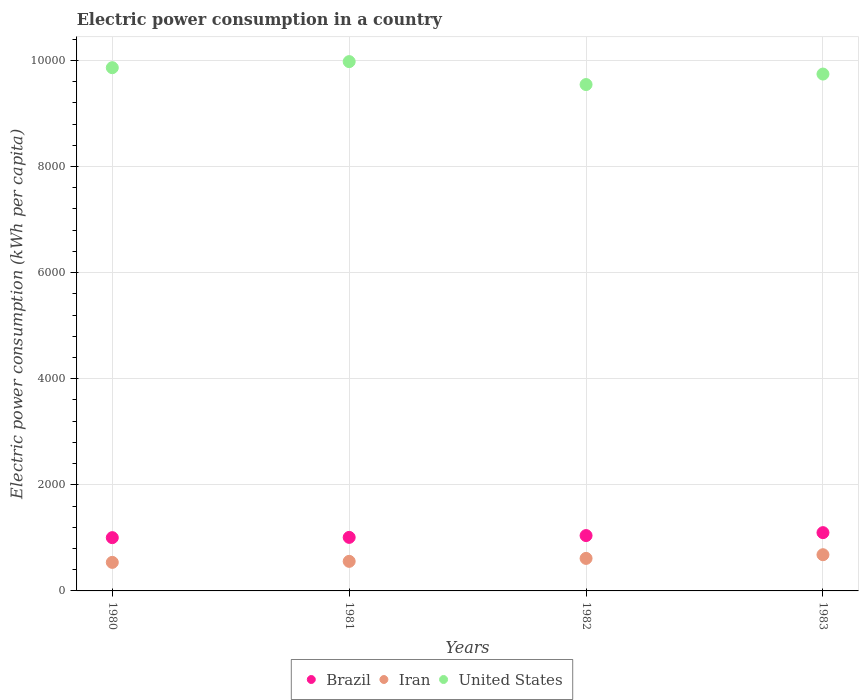How many different coloured dotlines are there?
Offer a very short reply. 3. What is the electric power consumption in in Brazil in 1980?
Provide a short and direct response. 1004.13. Across all years, what is the maximum electric power consumption in in United States?
Keep it short and to the point. 9976.69. Across all years, what is the minimum electric power consumption in in Iran?
Keep it short and to the point. 537.91. In which year was the electric power consumption in in Iran maximum?
Keep it short and to the point. 1983. What is the total electric power consumption in in Iran in the graph?
Offer a terse response. 2390.61. What is the difference between the electric power consumption in in Iran in 1982 and that in 1983?
Your answer should be compact. -69.37. What is the difference between the electric power consumption in in United States in 1983 and the electric power consumption in in Brazil in 1982?
Provide a short and direct response. 8698.89. What is the average electric power consumption in in Iran per year?
Give a very brief answer. 597.65. In the year 1983, what is the difference between the electric power consumption in in United States and electric power consumption in in Brazil?
Make the answer very short. 8643.54. In how many years, is the electric power consumption in in Brazil greater than 1200 kWh per capita?
Offer a very short reply. 0. What is the ratio of the electric power consumption in in United States in 1980 to that in 1982?
Keep it short and to the point. 1.03. Is the electric power consumption in in United States in 1980 less than that in 1983?
Offer a terse response. No. What is the difference between the highest and the second highest electric power consumption in in United States?
Provide a short and direct response. 114.33. What is the difference between the highest and the lowest electric power consumption in in Brazil?
Offer a terse response. 94.34. In how many years, is the electric power consumption in in Brazil greater than the average electric power consumption in in Brazil taken over all years?
Your response must be concise. 2. Is the sum of the electric power consumption in in United States in 1981 and 1983 greater than the maximum electric power consumption in in Iran across all years?
Provide a short and direct response. Yes. Is it the case that in every year, the sum of the electric power consumption in in Iran and electric power consumption in in United States  is greater than the electric power consumption in in Brazil?
Provide a short and direct response. Yes. Is the electric power consumption in in United States strictly less than the electric power consumption in in Iran over the years?
Make the answer very short. No. How many dotlines are there?
Offer a very short reply. 3. What is the difference between two consecutive major ticks on the Y-axis?
Offer a very short reply. 2000. Are the values on the major ticks of Y-axis written in scientific E-notation?
Make the answer very short. No. What is the title of the graph?
Offer a very short reply. Electric power consumption in a country. What is the label or title of the X-axis?
Offer a terse response. Years. What is the label or title of the Y-axis?
Your answer should be very brief. Electric power consumption (kWh per capita). What is the Electric power consumption (kWh per capita) of Brazil in 1980?
Make the answer very short. 1004.13. What is the Electric power consumption (kWh per capita) of Iran in 1980?
Your answer should be compact. 537.91. What is the Electric power consumption (kWh per capita) in United States in 1980?
Your response must be concise. 9862.37. What is the Electric power consumption (kWh per capita) of Brazil in 1981?
Your answer should be compact. 1009. What is the Electric power consumption (kWh per capita) in Iran in 1981?
Keep it short and to the point. 557.31. What is the Electric power consumption (kWh per capita) of United States in 1981?
Offer a terse response. 9976.69. What is the Electric power consumption (kWh per capita) of Brazil in 1982?
Ensure brevity in your answer.  1043.12. What is the Electric power consumption (kWh per capita) of Iran in 1982?
Make the answer very short. 613.01. What is the Electric power consumption (kWh per capita) in United States in 1982?
Ensure brevity in your answer.  9544.46. What is the Electric power consumption (kWh per capita) in Brazil in 1983?
Provide a succinct answer. 1098.47. What is the Electric power consumption (kWh per capita) of Iran in 1983?
Provide a succinct answer. 682.38. What is the Electric power consumption (kWh per capita) in United States in 1983?
Your answer should be very brief. 9742.01. Across all years, what is the maximum Electric power consumption (kWh per capita) in Brazil?
Your answer should be very brief. 1098.47. Across all years, what is the maximum Electric power consumption (kWh per capita) of Iran?
Make the answer very short. 682.38. Across all years, what is the maximum Electric power consumption (kWh per capita) of United States?
Offer a very short reply. 9976.69. Across all years, what is the minimum Electric power consumption (kWh per capita) in Brazil?
Give a very brief answer. 1004.13. Across all years, what is the minimum Electric power consumption (kWh per capita) of Iran?
Your answer should be compact. 537.91. Across all years, what is the minimum Electric power consumption (kWh per capita) in United States?
Your answer should be very brief. 9544.46. What is the total Electric power consumption (kWh per capita) of Brazil in the graph?
Offer a very short reply. 4154.71. What is the total Electric power consumption (kWh per capita) in Iran in the graph?
Ensure brevity in your answer.  2390.61. What is the total Electric power consumption (kWh per capita) in United States in the graph?
Offer a very short reply. 3.91e+04. What is the difference between the Electric power consumption (kWh per capita) in Brazil in 1980 and that in 1981?
Your answer should be compact. -4.87. What is the difference between the Electric power consumption (kWh per capita) of Iran in 1980 and that in 1981?
Give a very brief answer. -19.4. What is the difference between the Electric power consumption (kWh per capita) of United States in 1980 and that in 1981?
Ensure brevity in your answer.  -114.33. What is the difference between the Electric power consumption (kWh per capita) in Brazil in 1980 and that in 1982?
Your answer should be very brief. -38.99. What is the difference between the Electric power consumption (kWh per capita) in Iran in 1980 and that in 1982?
Make the answer very short. -75.1. What is the difference between the Electric power consumption (kWh per capita) of United States in 1980 and that in 1982?
Your answer should be compact. 317.9. What is the difference between the Electric power consumption (kWh per capita) in Brazil in 1980 and that in 1983?
Your response must be concise. -94.34. What is the difference between the Electric power consumption (kWh per capita) of Iran in 1980 and that in 1983?
Provide a short and direct response. -144.47. What is the difference between the Electric power consumption (kWh per capita) in United States in 1980 and that in 1983?
Give a very brief answer. 120.36. What is the difference between the Electric power consumption (kWh per capita) in Brazil in 1981 and that in 1982?
Keep it short and to the point. -34.12. What is the difference between the Electric power consumption (kWh per capita) of Iran in 1981 and that in 1982?
Keep it short and to the point. -55.7. What is the difference between the Electric power consumption (kWh per capita) of United States in 1981 and that in 1982?
Ensure brevity in your answer.  432.23. What is the difference between the Electric power consumption (kWh per capita) of Brazil in 1981 and that in 1983?
Keep it short and to the point. -89.47. What is the difference between the Electric power consumption (kWh per capita) of Iran in 1981 and that in 1983?
Your answer should be very brief. -125.07. What is the difference between the Electric power consumption (kWh per capita) of United States in 1981 and that in 1983?
Offer a terse response. 234.69. What is the difference between the Electric power consumption (kWh per capita) in Brazil in 1982 and that in 1983?
Your response must be concise. -55.35. What is the difference between the Electric power consumption (kWh per capita) of Iran in 1982 and that in 1983?
Ensure brevity in your answer.  -69.37. What is the difference between the Electric power consumption (kWh per capita) of United States in 1982 and that in 1983?
Keep it short and to the point. -197.54. What is the difference between the Electric power consumption (kWh per capita) in Brazil in 1980 and the Electric power consumption (kWh per capita) in Iran in 1981?
Give a very brief answer. 446.81. What is the difference between the Electric power consumption (kWh per capita) of Brazil in 1980 and the Electric power consumption (kWh per capita) of United States in 1981?
Your response must be concise. -8972.57. What is the difference between the Electric power consumption (kWh per capita) of Iran in 1980 and the Electric power consumption (kWh per capita) of United States in 1981?
Provide a short and direct response. -9438.78. What is the difference between the Electric power consumption (kWh per capita) in Brazil in 1980 and the Electric power consumption (kWh per capita) in Iran in 1982?
Provide a succinct answer. 391.12. What is the difference between the Electric power consumption (kWh per capita) in Brazil in 1980 and the Electric power consumption (kWh per capita) in United States in 1982?
Your response must be concise. -8540.33. What is the difference between the Electric power consumption (kWh per capita) of Iran in 1980 and the Electric power consumption (kWh per capita) of United States in 1982?
Keep it short and to the point. -9006.55. What is the difference between the Electric power consumption (kWh per capita) in Brazil in 1980 and the Electric power consumption (kWh per capita) in Iran in 1983?
Give a very brief answer. 321.75. What is the difference between the Electric power consumption (kWh per capita) of Brazil in 1980 and the Electric power consumption (kWh per capita) of United States in 1983?
Keep it short and to the point. -8737.88. What is the difference between the Electric power consumption (kWh per capita) in Iran in 1980 and the Electric power consumption (kWh per capita) in United States in 1983?
Keep it short and to the point. -9204.1. What is the difference between the Electric power consumption (kWh per capita) in Brazil in 1981 and the Electric power consumption (kWh per capita) in Iran in 1982?
Your answer should be compact. 395.99. What is the difference between the Electric power consumption (kWh per capita) of Brazil in 1981 and the Electric power consumption (kWh per capita) of United States in 1982?
Make the answer very short. -8535.46. What is the difference between the Electric power consumption (kWh per capita) in Iran in 1981 and the Electric power consumption (kWh per capita) in United States in 1982?
Your response must be concise. -8987.15. What is the difference between the Electric power consumption (kWh per capita) of Brazil in 1981 and the Electric power consumption (kWh per capita) of Iran in 1983?
Offer a terse response. 326.62. What is the difference between the Electric power consumption (kWh per capita) in Brazil in 1981 and the Electric power consumption (kWh per capita) in United States in 1983?
Your answer should be very brief. -8733.01. What is the difference between the Electric power consumption (kWh per capita) of Iran in 1981 and the Electric power consumption (kWh per capita) of United States in 1983?
Ensure brevity in your answer.  -9184.69. What is the difference between the Electric power consumption (kWh per capita) of Brazil in 1982 and the Electric power consumption (kWh per capita) of Iran in 1983?
Ensure brevity in your answer.  360.73. What is the difference between the Electric power consumption (kWh per capita) in Brazil in 1982 and the Electric power consumption (kWh per capita) in United States in 1983?
Make the answer very short. -8698.89. What is the difference between the Electric power consumption (kWh per capita) in Iran in 1982 and the Electric power consumption (kWh per capita) in United States in 1983?
Provide a succinct answer. -9129. What is the average Electric power consumption (kWh per capita) in Brazil per year?
Keep it short and to the point. 1038.68. What is the average Electric power consumption (kWh per capita) of Iran per year?
Offer a very short reply. 597.65. What is the average Electric power consumption (kWh per capita) of United States per year?
Your answer should be compact. 9781.38. In the year 1980, what is the difference between the Electric power consumption (kWh per capita) of Brazil and Electric power consumption (kWh per capita) of Iran?
Offer a terse response. 466.22. In the year 1980, what is the difference between the Electric power consumption (kWh per capita) of Brazil and Electric power consumption (kWh per capita) of United States?
Your response must be concise. -8858.24. In the year 1980, what is the difference between the Electric power consumption (kWh per capita) of Iran and Electric power consumption (kWh per capita) of United States?
Your answer should be very brief. -9324.46. In the year 1981, what is the difference between the Electric power consumption (kWh per capita) of Brazil and Electric power consumption (kWh per capita) of Iran?
Offer a terse response. 451.69. In the year 1981, what is the difference between the Electric power consumption (kWh per capita) in Brazil and Electric power consumption (kWh per capita) in United States?
Your answer should be very brief. -8967.7. In the year 1981, what is the difference between the Electric power consumption (kWh per capita) of Iran and Electric power consumption (kWh per capita) of United States?
Your answer should be compact. -9419.38. In the year 1982, what is the difference between the Electric power consumption (kWh per capita) of Brazil and Electric power consumption (kWh per capita) of Iran?
Make the answer very short. 430.11. In the year 1982, what is the difference between the Electric power consumption (kWh per capita) in Brazil and Electric power consumption (kWh per capita) in United States?
Ensure brevity in your answer.  -8501.34. In the year 1982, what is the difference between the Electric power consumption (kWh per capita) of Iran and Electric power consumption (kWh per capita) of United States?
Keep it short and to the point. -8931.45. In the year 1983, what is the difference between the Electric power consumption (kWh per capita) in Brazil and Electric power consumption (kWh per capita) in Iran?
Provide a succinct answer. 416.09. In the year 1983, what is the difference between the Electric power consumption (kWh per capita) of Brazil and Electric power consumption (kWh per capita) of United States?
Provide a short and direct response. -8643.54. In the year 1983, what is the difference between the Electric power consumption (kWh per capita) of Iran and Electric power consumption (kWh per capita) of United States?
Keep it short and to the point. -9059.62. What is the ratio of the Electric power consumption (kWh per capita) of Brazil in 1980 to that in 1981?
Offer a terse response. 1. What is the ratio of the Electric power consumption (kWh per capita) in Iran in 1980 to that in 1981?
Your response must be concise. 0.97. What is the ratio of the Electric power consumption (kWh per capita) of Brazil in 1980 to that in 1982?
Ensure brevity in your answer.  0.96. What is the ratio of the Electric power consumption (kWh per capita) in Iran in 1980 to that in 1982?
Offer a very short reply. 0.88. What is the ratio of the Electric power consumption (kWh per capita) of Brazil in 1980 to that in 1983?
Provide a short and direct response. 0.91. What is the ratio of the Electric power consumption (kWh per capita) in Iran in 1980 to that in 1983?
Offer a terse response. 0.79. What is the ratio of the Electric power consumption (kWh per capita) of United States in 1980 to that in 1983?
Offer a terse response. 1.01. What is the ratio of the Electric power consumption (kWh per capita) in Brazil in 1981 to that in 1982?
Ensure brevity in your answer.  0.97. What is the ratio of the Electric power consumption (kWh per capita) in Iran in 1981 to that in 1982?
Your answer should be compact. 0.91. What is the ratio of the Electric power consumption (kWh per capita) of United States in 1981 to that in 1982?
Your answer should be very brief. 1.05. What is the ratio of the Electric power consumption (kWh per capita) of Brazil in 1981 to that in 1983?
Give a very brief answer. 0.92. What is the ratio of the Electric power consumption (kWh per capita) of Iran in 1981 to that in 1983?
Provide a succinct answer. 0.82. What is the ratio of the Electric power consumption (kWh per capita) of United States in 1981 to that in 1983?
Your response must be concise. 1.02. What is the ratio of the Electric power consumption (kWh per capita) of Brazil in 1982 to that in 1983?
Make the answer very short. 0.95. What is the ratio of the Electric power consumption (kWh per capita) in Iran in 1982 to that in 1983?
Provide a succinct answer. 0.9. What is the ratio of the Electric power consumption (kWh per capita) in United States in 1982 to that in 1983?
Your response must be concise. 0.98. What is the difference between the highest and the second highest Electric power consumption (kWh per capita) of Brazil?
Make the answer very short. 55.35. What is the difference between the highest and the second highest Electric power consumption (kWh per capita) in Iran?
Give a very brief answer. 69.37. What is the difference between the highest and the second highest Electric power consumption (kWh per capita) of United States?
Your response must be concise. 114.33. What is the difference between the highest and the lowest Electric power consumption (kWh per capita) of Brazil?
Provide a short and direct response. 94.34. What is the difference between the highest and the lowest Electric power consumption (kWh per capita) of Iran?
Offer a terse response. 144.47. What is the difference between the highest and the lowest Electric power consumption (kWh per capita) of United States?
Your response must be concise. 432.23. 